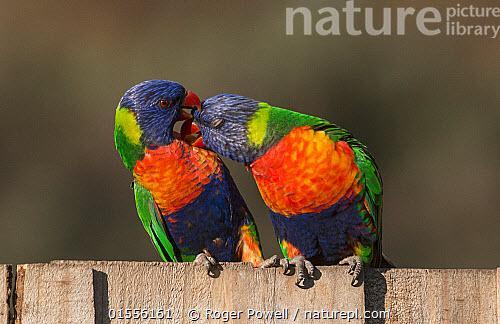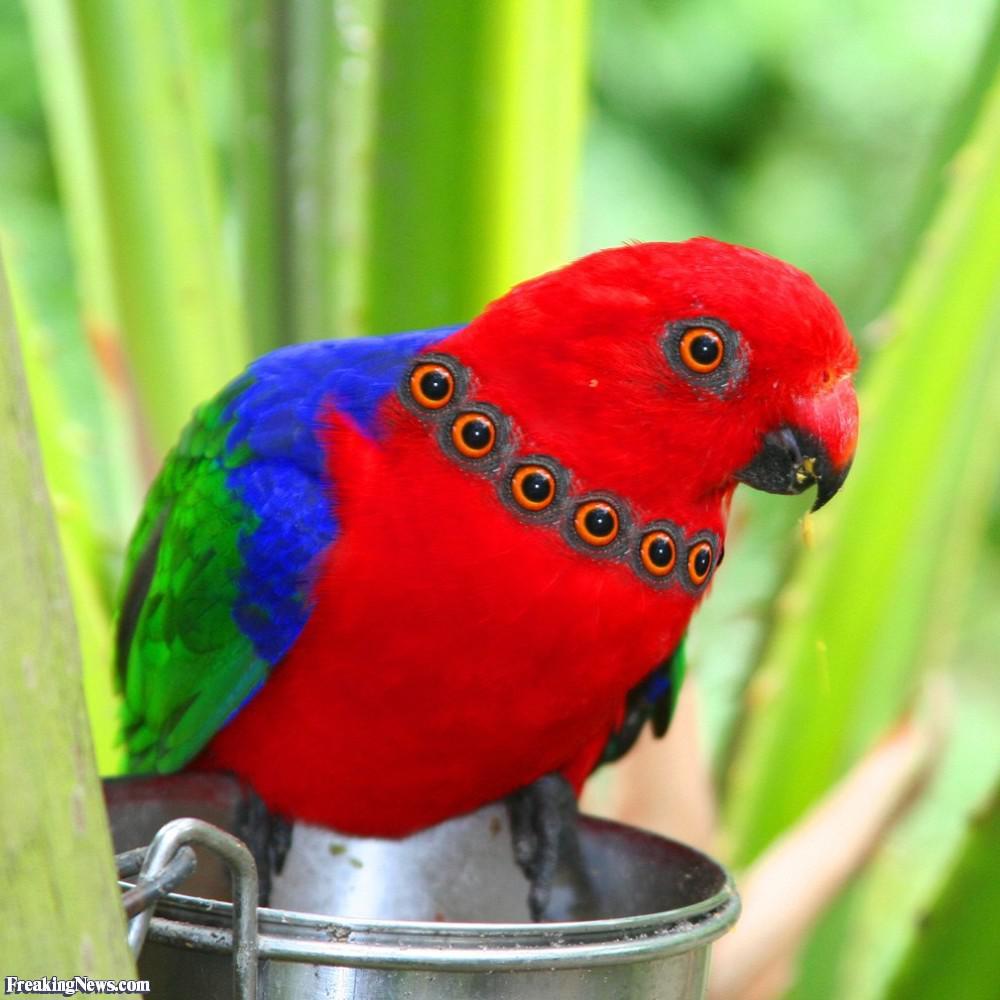The first image is the image on the left, the second image is the image on the right. Analyze the images presented: Is the assertion "Each image depicts exactly two multi-colored parrots." valid? Answer yes or no. No. The first image is the image on the left, the second image is the image on the right. Evaluate the accuracy of this statement regarding the images: "Two colorful birds are perched on a wooden fence.". Is it true? Answer yes or no. Yes. 